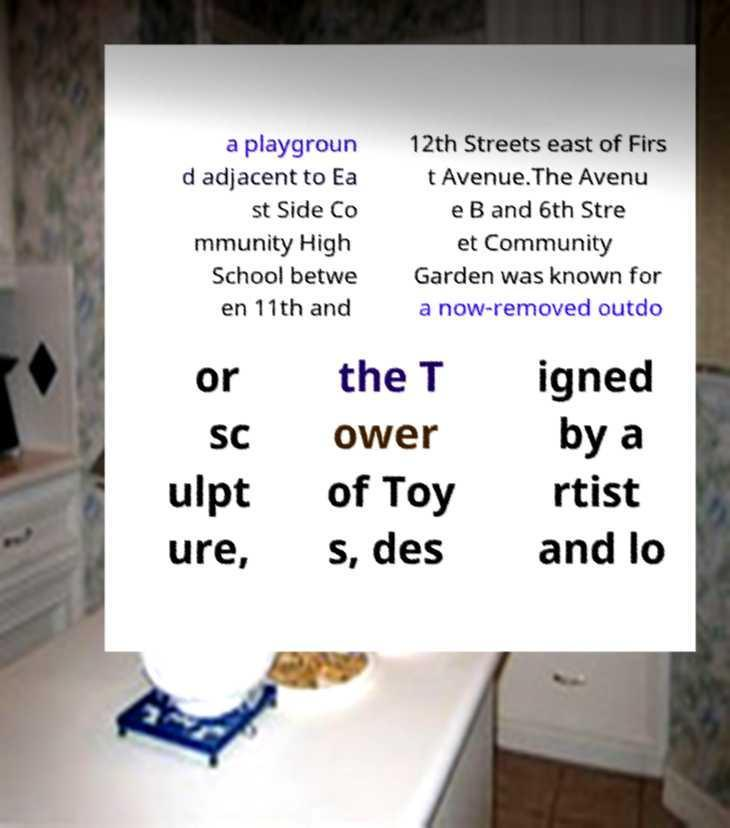What messages or text are displayed in this image? I need them in a readable, typed format. a playgroun d adjacent to Ea st Side Co mmunity High School betwe en 11th and 12th Streets east of Firs t Avenue.The Avenu e B and 6th Stre et Community Garden was known for a now-removed outdo or sc ulpt ure, the T ower of Toy s, des igned by a rtist and lo 